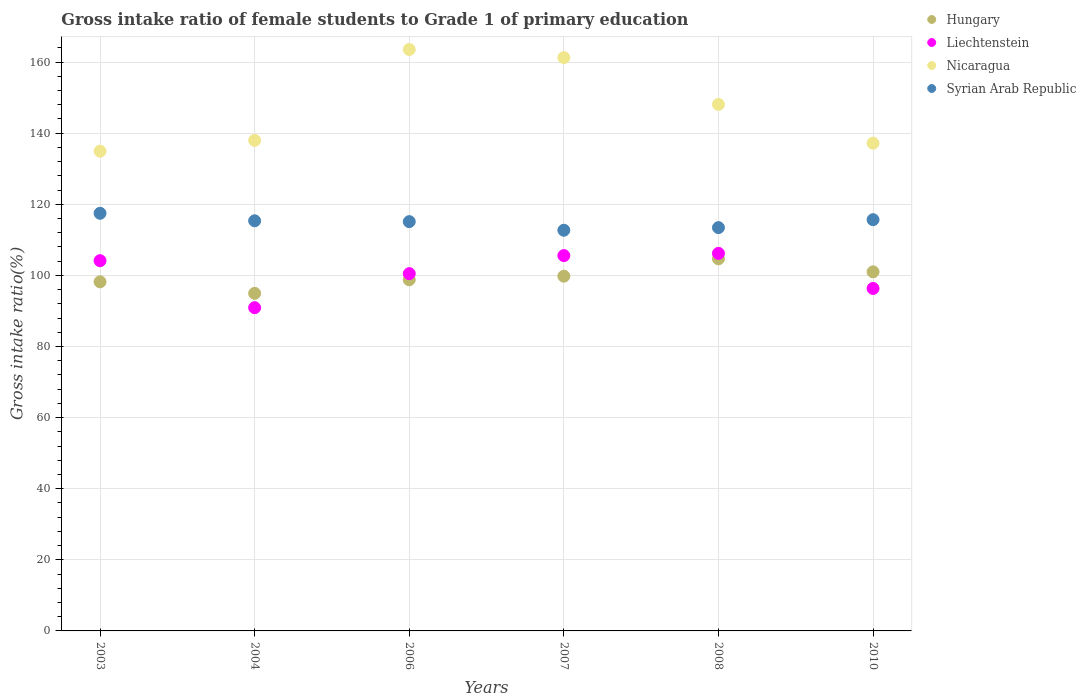How many different coloured dotlines are there?
Offer a very short reply. 4. What is the gross intake ratio in Syrian Arab Republic in 2006?
Ensure brevity in your answer.  115.11. Across all years, what is the maximum gross intake ratio in Liechtenstein?
Keep it short and to the point. 106.19. Across all years, what is the minimum gross intake ratio in Syrian Arab Republic?
Offer a very short reply. 112.68. In which year was the gross intake ratio in Hungary maximum?
Ensure brevity in your answer.  2008. What is the total gross intake ratio in Syrian Arab Republic in the graph?
Offer a very short reply. 689.66. What is the difference between the gross intake ratio in Nicaragua in 2004 and that in 2007?
Your response must be concise. -23.28. What is the difference between the gross intake ratio in Syrian Arab Republic in 2004 and the gross intake ratio in Nicaragua in 2007?
Your answer should be compact. -45.89. What is the average gross intake ratio in Liechtenstein per year?
Keep it short and to the point. 100.6. In the year 2003, what is the difference between the gross intake ratio in Liechtenstein and gross intake ratio in Syrian Arab Republic?
Offer a very short reply. -13.33. What is the ratio of the gross intake ratio in Liechtenstein in 2008 to that in 2010?
Provide a succinct answer. 1.1. Is the difference between the gross intake ratio in Liechtenstein in 2003 and 2004 greater than the difference between the gross intake ratio in Syrian Arab Republic in 2003 and 2004?
Ensure brevity in your answer.  Yes. What is the difference between the highest and the second highest gross intake ratio in Hungary?
Your answer should be very brief. 3.66. What is the difference between the highest and the lowest gross intake ratio in Liechtenstein?
Your answer should be very brief. 15.28. In how many years, is the gross intake ratio in Nicaragua greater than the average gross intake ratio in Nicaragua taken over all years?
Your response must be concise. 3. Is the sum of the gross intake ratio in Nicaragua in 2003 and 2006 greater than the maximum gross intake ratio in Hungary across all years?
Offer a very short reply. Yes. Is it the case that in every year, the sum of the gross intake ratio in Nicaragua and gross intake ratio in Liechtenstein  is greater than the sum of gross intake ratio in Hungary and gross intake ratio in Syrian Arab Republic?
Offer a very short reply. No. Does the gross intake ratio in Hungary monotonically increase over the years?
Provide a short and direct response. No. Is the gross intake ratio in Syrian Arab Republic strictly greater than the gross intake ratio in Hungary over the years?
Your response must be concise. Yes. How many dotlines are there?
Make the answer very short. 4. How many years are there in the graph?
Your response must be concise. 6. Are the values on the major ticks of Y-axis written in scientific E-notation?
Your answer should be compact. No. How many legend labels are there?
Provide a succinct answer. 4. What is the title of the graph?
Provide a short and direct response. Gross intake ratio of female students to Grade 1 of primary education. Does "United States" appear as one of the legend labels in the graph?
Give a very brief answer. No. What is the label or title of the Y-axis?
Your response must be concise. Gross intake ratio(%). What is the Gross intake ratio(%) of Hungary in 2003?
Your response must be concise. 98.18. What is the Gross intake ratio(%) of Liechtenstein in 2003?
Your response must be concise. 104.13. What is the Gross intake ratio(%) in Nicaragua in 2003?
Ensure brevity in your answer.  134.92. What is the Gross intake ratio(%) of Syrian Arab Republic in 2003?
Offer a terse response. 117.46. What is the Gross intake ratio(%) of Hungary in 2004?
Give a very brief answer. 94.94. What is the Gross intake ratio(%) of Liechtenstein in 2004?
Give a very brief answer. 90.91. What is the Gross intake ratio(%) of Nicaragua in 2004?
Your answer should be very brief. 137.96. What is the Gross intake ratio(%) in Syrian Arab Republic in 2004?
Your response must be concise. 115.34. What is the Gross intake ratio(%) in Hungary in 2006?
Make the answer very short. 98.75. What is the Gross intake ratio(%) of Liechtenstein in 2006?
Keep it short and to the point. 100.48. What is the Gross intake ratio(%) of Nicaragua in 2006?
Keep it short and to the point. 163.52. What is the Gross intake ratio(%) of Syrian Arab Republic in 2006?
Give a very brief answer. 115.11. What is the Gross intake ratio(%) of Hungary in 2007?
Make the answer very short. 99.76. What is the Gross intake ratio(%) in Liechtenstein in 2007?
Provide a succinct answer. 105.56. What is the Gross intake ratio(%) in Nicaragua in 2007?
Your response must be concise. 161.24. What is the Gross intake ratio(%) in Syrian Arab Republic in 2007?
Provide a succinct answer. 112.68. What is the Gross intake ratio(%) in Hungary in 2008?
Your response must be concise. 104.65. What is the Gross intake ratio(%) of Liechtenstein in 2008?
Ensure brevity in your answer.  106.19. What is the Gross intake ratio(%) of Nicaragua in 2008?
Your response must be concise. 148.06. What is the Gross intake ratio(%) in Syrian Arab Republic in 2008?
Your response must be concise. 113.42. What is the Gross intake ratio(%) in Hungary in 2010?
Your answer should be compact. 100.99. What is the Gross intake ratio(%) of Liechtenstein in 2010?
Your response must be concise. 96.32. What is the Gross intake ratio(%) of Nicaragua in 2010?
Provide a short and direct response. 137.17. What is the Gross intake ratio(%) of Syrian Arab Republic in 2010?
Offer a very short reply. 115.65. Across all years, what is the maximum Gross intake ratio(%) in Hungary?
Your answer should be very brief. 104.65. Across all years, what is the maximum Gross intake ratio(%) of Liechtenstein?
Make the answer very short. 106.19. Across all years, what is the maximum Gross intake ratio(%) of Nicaragua?
Keep it short and to the point. 163.52. Across all years, what is the maximum Gross intake ratio(%) in Syrian Arab Republic?
Your answer should be compact. 117.46. Across all years, what is the minimum Gross intake ratio(%) in Hungary?
Keep it short and to the point. 94.94. Across all years, what is the minimum Gross intake ratio(%) of Liechtenstein?
Provide a short and direct response. 90.91. Across all years, what is the minimum Gross intake ratio(%) in Nicaragua?
Provide a succinct answer. 134.92. Across all years, what is the minimum Gross intake ratio(%) of Syrian Arab Republic?
Provide a succinct answer. 112.68. What is the total Gross intake ratio(%) in Hungary in the graph?
Make the answer very short. 597.27. What is the total Gross intake ratio(%) in Liechtenstein in the graph?
Keep it short and to the point. 603.58. What is the total Gross intake ratio(%) of Nicaragua in the graph?
Keep it short and to the point. 882.87. What is the total Gross intake ratio(%) of Syrian Arab Republic in the graph?
Offer a terse response. 689.66. What is the difference between the Gross intake ratio(%) in Hungary in 2003 and that in 2004?
Your answer should be compact. 3.24. What is the difference between the Gross intake ratio(%) of Liechtenstein in 2003 and that in 2004?
Offer a terse response. 13.22. What is the difference between the Gross intake ratio(%) in Nicaragua in 2003 and that in 2004?
Your response must be concise. -3.04. What is the difference between the Gross intake ratio(%) in Syrian Arab Republic in 2003 and that in 2004?
Your answer should be compact. 2.11. What is the difference between the Gross intake ratio(%) in Hungary in 2003 and that in 2006?
Ensure brevity in your answer.  -0.57. What is the difference between the Gross intake ratio(%) in Liechtenstein in 2003 and that in 2006?
Give a very brief answer. 3.65. What is the difference between the Gross intake ratio(%) of Nicaragua in 2003 and that in 2006?
Your response must be concise. -28.6. What is the difference between the Gross intake ratio(%) in Syrian Arab Republic in 2003 and that in 2006?
Provide a short and direct response. 2.35. What is the difference between the Gross intake ratio(%) in Hungary in 2003 and that in 2007?
Provide a succinct answer. -1.58. What is the difference between the Gross intake ratio(%) in Liechtenstein in 2003 and that in 2007?
Your answer should be compact. -1.43. What is the difference between the Gross intake ratio(%) in Nicaragua in 2003 and that in 2007?
Your response must be concise. -26.32. What is the difference between the Gross intake ratio(%) of Syrian Arab Republic in 2003 and that in 2007?
Offer a very short reply. 4.77. What is the difference between the Gross intake ratio(%) in Hungary in 2003 and that in 2008?
Provide a succinct answer. -6.47. What is the difference between the Gross intake ratio(%) of Liechtenstein in 2003 and that in 2008?
Your response must be concise. -2.06. What is the difference between the Gross intake ratio(%) in Nicaragua in 2003 and that in 2008?
Ensure brevity in your answer.  -13.15. What is the difference between the Gross intake ratio(%) in Syrian Arab Republic in 2003 and that in 2008?
Offer a terse response. 4.03. What is the difference between the Gross intake ratio(%) in Hungary in 2003 and that in 2010?
Provide a short and direct response. -2.81. What is the difference between the Gross intake ratio(%) in Liechtenstein in 2003 and that in 2010?
Offer a very short reply. 7.81. What is the difference between the Gross intake ratio(%) in Nicaragua in 2003 and that in 2010?
Provide a succinct answer. -2.25. What is the difference between the Gross intake ratio(%) in Syrian Arab Republic in 2003 and that in 2010?
Offer a very short reply. 1.81. What is the difference between the Gross intake ratio(%) of Hungary in 2004 and that in 2006?
Your answer should be compact. -3.82. What is the difference between the Gross intake ratio(%) in Liechtenstein in 2004 and that in 2006?
Provide a short and direct response. -9.57. What is the difference between the Gross intake ratio(%) of Nicaragua in 2004 and that in 2006?
Your answer should be very brief. -25.56. What is the difference between the Gross intake ratio(%) in Syrian Arab Republic in 2004 and that in 2006?
Offer a terse response. 0.23. What is the difference between the Gross intake ratio(%) in Hungary in 2004 and that in 2007?
Offer a very short reply. -4.83. What is the difference between the Gross intake ratio(%) of Liechtenstein in 2004 and that in 2007?
Your response must be concise. -14.65. What is the difference between the Gross intake ratio(%) of Nicaragua in 2004 and that in 2007?
Ensure brevity in your answer.  -23.28. What is the difference between the Gross intake ratio(%) in Syrian Arab Republic in 2004 and that in 2007?
Provide a short and direct response. 2.66. What is the difference between the Gross intake ratio(%) of Hungary in 2004 and that in 2008?
Give a very brief answer. -9.71. What is the difference between the Gross intake ratio(%) of Liechtenstein in 2004 and that in 2008?
Offer a very short reply. -15.28. What is the difference between the Gross intake ratio(%) of Nicaragua in 2004 and that in 2008?
Provide a short and direct response. -10.1. What is the difference between the Gross intake ratio(%) of Syrian Arab Republic in 2004 and that in 2008?
Your answer should be very brief. 1.92. What is the difference between the Gross intake ratio(%) in Hungary in 2004 and that in 2010?
Your response must be concise. -6.05. What is the difference between the Gross intake ratio(%) in Liechtenstein in 2004 and that in 2010?
Offer a terse response. -5.41. What is the difference between the Gross intake ratio(%) in Nicaragua in 2004 and that in 2010?
Give a very brief answer. 0.79. What is the difference between the Gross intake ratio(%) of Syrian Arab Republic in 2004 and that in 2010?
Give a very brief answer. -0.31. What is the difference between the Gross intake ratio(%) of Hungary in 2006 and that in 2007?
Provide a short and direct response. -1.01. What is the difference between the Gross intake ratio(%) in Liechtenstein in 2006 and that in 2007?
Give a very brief answer. -5.07. What is the difference between the Gross intake ratio(%) of Nicaragua in 2006 and that in 2007?
Keep it short and to the point. 2.29. What is the difference between the Gross intake ratio(%) of Syrian Arab Republic in 2006 and that in 2007?
Keep it short and to the point. 2.42. What is the difference between the Gross intake ratio(%) in Hungary in 2006 and that in 2008?
Offer a terse response. -5.9. What is the difference between the Gross intake ratio(%) of Liechtenstein in 2006 and that in 2008?
Provide a succinct answer. -5.7. What is the difference between the Gross intake ratio(%) of Nicaragua in 2006 and that in 2008?
Make the answer very short. 15.46. What is the difference between the Gross intake ratio(%) of Syrian Arab Republic in 2006 and that in 2008?
Give a very brief answer. 1.68. What is the difference between the Gross intake ratio(%) of Hungary in 2006 and that in 2010?
Offer a very short reply. -2.24. What is the difference between the Gross intake ratio(%) in Liechtenstein in 2006 and that in 2010?
Provide a short and direct response. 4.17. What is the difference between the Gross intake ratio(%) in Nicaragua in 2006 and that in 2010?
Make the answer very short. 26.35. What is the difference between the Gross intake ratio(%) of Syrian Arab Republic in 2006 and that in 2010?
Give a very brief answer. -0.54. What is the difference between the Gross intake ratio(%) of Hungary in 2007 and that in 2008?
Provide a short and direct response. -4.89. What is the difference between the Gross intake ratio(%) of Liechtenstein in 2007 and that in 2008?
Your answer should be compact. -0.63. What is the difference between the Gross intake ratio(%) in Nicaragua in 2007 and that in 2008?
Give a very brief answer. 13.17. What is the difference between the Gross intake ratio(%) in Syrian Arab Republic in 2007 and that in 2008?
Offer a very short reply. -0.74. What is the difference between the Gross intake ratio(%) of Hungary in 2007 and that in 2010?
Provide a succinct answer. -1.23. What is the difference between the Gross intake ratio(%) of Liechtenstein in 2007 and that in 2010?
Your answer should be compact. 9.24. What is the difference between the Gross intake ratio(%) of Nicaragua in 2007 and that in 2010?
Provide a succinct answer. 24.07. What is the difference between the Gross intake ratio(%) in Syrian Arab Republic in 2007 and that in 2010?
Make the answer very short. -2.97. What is the difference between the Gross intake ratio(%) of Hungary in 2008 and that in 2010?
Provide a short and direct response. 3.66. What is the difference between the Gross intake ratio(%) in Liechtenstein in 2008 and that in 2010?
Keep it short and to the point. 9.87. What is the difference between the Gross intake ratio(%) of Nicaragua in 2008 and that in 2010?
Provide a succinct answer. 10.9. What is the difference between the Gross intake ratio(%) of Syrian Arab Republic in 2008 and that in 2010?
Your answer should be compact. -2.23. What is the difference between the Gross intake ratio(%) in Hungary in 2003 and the Gross intake ratio(%) in Liechtenstein in 2004?
Keep it short and to the point. 7.27. What is the difference between the Gross intake ratio(%) of Hungary in 2003 and the Gross intake ratio(%) of Nicaragua in 2004?
Offer a terse response. -39.78. What is the difference between the Gross intake ratio(%) in Hungary in 2003 and the Gross intake ratio(%) in Syrian Arab Republic in 2004?
Keep it short and to the point. -17.16. What is the difference between the Gross intake ratio(%) of Liechtenstein in 2003 and the Gross intake ratio(%) of Nicaragua in 2004?
Your response must be concise. -33.83. What is the difference between the Gross intake ratio(%) in Liechtenstein in 2003 and the Gross intake ratio(%) in Syrian Arab Republic in 2004?
Your answer should be very brief. -11.21. What is the difference between the Gross intake ratio(%) of Nicaragua in 2003 and the Gross intake ratio(%) of Syrian Arab Republic in 2004?
Your answer should be compact. 19.58. What is the difference between the Gross intake ratio(%) in Hungary in 2003 and the Gross intake ratio(%) in Liechtenstein in 2006?
Provide a short and direct response. -2.3. What is the difference between the Gross intake ratio(%) of Hungary in 2003 and the Gross intake ratio(%) of Nicaragua in 2006?
Offer a terse response. -65.34. What is the difference between the Gross intake ratio(%) of Hungary in 2003 and the Gross intake ratio(%) of Syrian Arab Republic in 2006?
Your response must be concise. -16.93. What is the difference between the Gross intake ratio(%) of Liechtenstein in 2003 and the Gross intake ratio(%) of Nicaragua in 2006?
Your answer should be compact. -59.39. What is the difference between the Gross intake ratio(%) of Liechtenstein in 2003 and the Gross intake ratio(%) of Syrian Arab Republic in 2006?
Keep it short and to the point. -10.98. What is the difference between the Gross intake ratio(%) of Nicaragua in 2003 and the Gross intake ratio(%) of Syrian Arab Republic in 2006?
Keep it short and to the point. 19.81. What is the difference between the Gross intake ratio(%) of Hungary in 2003 and the Gross intake ratio(%) of Liechtenstein in 2007?
Give a very brief answer. -7.38. What is the difference between the Gross intake ratio(%) of Hungary in 2003 and the Gross intake ratio(%) of Nicaragua in 2007?
Make the answer very short. -63.06. What is the difference between the Gross intake ratio(%) in Hungary in 2003 and the Gross intake ratio(%) in Syrian Arab Republic in 2007?
Offer a terse response. -14.5. What is the difference between the Gross intake ratio(%) in Liechtenstein in 2003 and the Gross intake ratio(%) in Nicaragua in 2007?
Your response must be concise. -57.11. What is the difference between the Gross intake ratio(%) of Liechtenstein in 2003 and the Gross intake ratio(%) of Syrian Arab Republic in 2007?
Ensure brevity in your answer.  -8.56. What is the difference between the Gross intake ratio(%) of Nicaragua in 2003 and the Gross intake ratio(%) of Syrian Arab Republic in 2007?
Provide a short and direct response. 22.23. What is the difference between the Gross intake ratio(%) in Hungary in 2003 and the Gross intake ratio(%) in Liechtenstein in 2008?
Offer a terse response. -8.01. What is the difference between the Gross intake ratio(%) of Hungary in 2003 and the Gross intake ratio(%) of Nicaragua in 2008?
Keep it short and to the point. -49.88. What is the difference between the Gross intake ratio(%) of Hungary in 2003 and the Gross intake ratio(%) of Syrian Arab Republic in 2008?
Provide a short and direct response. -15.24. What is the difference between the Gross intake ratio(%) of Liechtenstein in 2003 and the Gross intake ratio(%) of Nicaragua in 2008?
Provide a short and direct response. -43.94. What is the difference between the Gross intake ratio(%) of Liechtenstein in 2003 and the Gross intake ratio(%) of Syrian Arab Republic in 2008?
Your answer should be compact. -9.29. What is the difference between the Gross intake ratio(%) of Nicaragua in 2003 and the Gross intake ratio(%) of Syrian Arab Republic in 2008?
Give a very brief answer. 21.5. What is the difference between the Gross intake ratio(%) in Hungary in 2003 and the Gross intake ratio(%) in Liechtenstein in 2010?
Your answer should be compact. 1.86. What is the difference between the Gross intake ratio(%) of Hungary in 2003 and the Gross intake ratio(%) of Nicaragua in 2010?
Give a very brief answer. -38.99. What is the difference between the Gross intake ratio(%) in Hungary in 2003 and the Gross intake ratio(%) in Syrian Arab Republic in 2010?
Ensure brevity in your answer.  -17.47. What is the difference between the Gross intake ratio(%) of Liechtenstein in 2003 and the Gross intake ratio(%) of Nicaragua in 2010?
Ensure brevity in your answer.  -33.04. What is the difference between the Gross intake ratio(%) in Liechtenstein in 2003 and the Gross intake ratio(%) in Syrian Arab Republic in 2010?
Keep it short and to the point. -11.52. What is the difference between the Gross intake ratio(%) of Nicaragua in 2003 and the Gross intake ratio(%) of Syrian Arab Republic in 2010?
Offer a terse response. 19.27. What is the difference between the Gross intake ratio(%) of Hungary in 2004 and the Gross intake ratio(%) of Liechtenstein in 2006?
Ensure brevity in your answer.  -5.55. What is the difference between the Gross intake ratio(%) in Hungary in 2004 and the Gross intake ratio(%) in Nicaragua in 2006?
Your answer should be very brief. -68.59. What is the difference between the Gross intake ratio(%) in Hungary in 2004 and the Gross intake ratio(%) in Syrian Arab Republic in 2006?
Provide a short and direct response. -20.17. What is the difference between the Gross intake ratio(%) of Liechtenstein in 2004 and the Gross intake ratio(%) of Nicaragua in 2006?
Provide a succinct answer. -72.61. What is the difference between the Gross intake ratio(%) of Liechtenstein in 2004 and the Gross intake ratio(%) of Syrian Arab Republic in 2006?
Make the answer very short. -24.2. What is the difference between the Gross intake ratio(%) of Nicaragua in 2004 and the Gross intake ratio(%) of Syrian Arab Republic in 2006?
Provide a succinct answer. 22.85. What is the difference between the Gross intake ratio(%) in Hungary in 2004 and the Gross intake ratio(%) in Liechtenstein in 2007?
Make the answer very short. -10.62. What is the difference between the Gross intake ratio(%) in Hungary in 2004 and the Gross intake ratio(%) in Nicaragua in 2007?
Make the answer very short. -66.3. What is the difference between the Gross intake ratio(%) of Hungary in 2004 and the Gross intake ratio(%) of Syrian Arab Republic in 2007?
Offer a terse response. -17.75. What is the difference between the Gross intake ratio(%) in Liechtenstein in 2004 and the Gross intake ratio(%) in Nicaragua in 2007?
Ensure brevity in your answer.  -70.33. What is the difference between the Gross intake ratio(%) of Liechtenstein in 2004 and the Gross intake ratio(%) of Syrian Arab Republic in 2007?
Provide a short and direct response. -21.77. What is the difference between the Gross intake ratio(%) in Nicaragua in 2004 and the Gross intake ratio(%) in Syrian Arab Republic in 2007?
Ensure brevity in your answer.  25.28. What is the difference between the Gross intake ratio(%) in Hungary in 2004 and the Gross intake ratio(%) in Liechtenstein in 2008?
Give a very brief answer. -11.25. What is the difference between the Gross intake ratio(%) of Hungary in 2004 and the Gross intake ratio(%) of Nicaragua in 2008?
Provide a succinct answer. -53.13. What is the difference between the Gross intake ratio(%) of Hungary in 2004 and the Gross intake ratio(%) of Syrian Arab Republic in 2008?
Provide a succinct answer. -18.49. What is the difference between the Gross intake ratio(%) in Liechtenstein in 2004 and the Gross intake ratio(%) in Nicaragua in 2008?
Keep it short and to the point. -57.15. What is the difference between the Gross intake ratio(%) in Liechtenstein in 2004 and the Gross intake ratio(%) in Syrian Arab Republic in 2008?
Your answer should be compact. -22.51. What is the difference between the Gross intake ratio(%) in Nicaragua in 2004 and the Gross intake ratio(%) in Syrian Arab Republic in 2008?
Your response must be concise. 24.54. What is the difference between the Gross intake ratio(%) of Hungary in 2004 and the Gross intake ratio(%) of Liechtenstein in 2010?
Provide a succinct answer. -1.38. What is the difference between the Gross intake ratio(%) of Hungary in 2004 and the Gross intake ratio(%) of Nicaragua in 2010?
Provide a succinct answer. -42.23. What is the difference between the Gross intake ratio(%) in Hungary in 2004 and the Gross intake ratio(%) in Syrian Arab Republic in 2010?
Provide a short and direct response. -20.71. What is the difference between the Gross intake ratio(%) of Liechtenstein in 2004 and the Gross intake ratio(%) of Nicaragua in 2010?
Give a very brief answer. -46.26. What is the difference between the Gross intake ratio(%) in Liechtenstein in 2004 and the Gross intake ratio(%) in Syrian Arab Republic in 2010?
Your answer should be very brief. -24.74. What is the difference between the Gross intake ratio(%) in Nicaragua in 2004 and the Gross intake ratio(%) in Syrian Arab Republic in 2010?
Ensure brevity in your answer.  22.31. What is the difference between the Gross intake ratio(%) of Hungary in 2006 and the Gross intake ratio(%) of Liechtenstein in 2007?
Make the answer very short. -6.8. What is the difference between the Gross intake ratio(%) of Hungary in 2006 and the Gross intake ratio(%) of Nicaragua in 2007?
Make the answer very short. -62.48. What is the difference between the Gross intake ratio(%) in Hungary in 2006 and the Gross intake ratio(%) in Syrian Arab Republic in 2007?
Provide a succinct answer. -13.93. What is the difference between the Gross intake ratio(%) in Liechtenstein in 2006 and the Gross intake ratio(%) in Nicaragua in 2007?
Provide a succinct answer. -60.75. What is the difference between the Gross intake ratio(%) in Liechtenstein in 2006 and the Gross intake ratio(%) in Syrian Arab Republic in 2007?
Your response must be concise. -12.2. What is the difference between the Gross intake ratio(%) in Nicaragua in 2006 and the Gross intake ratio(%) in Syrian Arab Republic in 2007?
Offer a very short reply. 50.84. What is the difference between the Gross intake ratio(%) of Hungary in 2006 and the Gross intake ratio(%) of Liechtenstein in 2008?
Make the answer very short. -7.43. What is the difference between the Gross intake ratio(%) of Hungary in 2006 and the Gross intake ratio(%) of Nicaragua in 2008?
Provide a succinct answer. -49.31. What is the difference between the Gross intake ratio(%) of Hungary in 2006 and the Gross intake ratio(%) of Syrian Arab Republic in 2008?
Offer a terse response. -14.67. What is the difference between the Gross intake ratio(%) of Liechtenstein in 2006 and the Gross intake ratio(%) of Nicaragua in 2008?
Give a very brief answer. -47.58. What is the difference between the Gross intake ratio(%) of Liechtenstein in 2006 and the Gross intake ratio(%) of Syrian Arab Republic in 2008?
Offer a terse response. -12.94. What is the difference between the Gross intake ratio(%) in Nicaragua in 2006 and the Gross intake ratio(%) in Syrian Arab Republic in 2008?
Provide a short and direct response. 50.1. What is the difference between the Gross intake ratio(%) in Hungary in 2006 and the Gross intake ratio(%) in Liechtenstein in 2010?
Keep it short and to the point. 2.44. What is the difference between the Gross intake ratio(%) in Hungary in 2006 and the Gross intake ratio(%) in Nicaragua in 2010?
Provide a succinct answer. -38.41. What is the difference between the Gross intake ratio(%) in Hungary in 2006 and the Gross intake ratio(%) in Syrian Arab Republic in 2010?
Your answer should be very brief. -16.9. What is the difference between the Gross intake ratio(%) in Liechtenstein in 2006 and the Gross intake ratio(%) in Nicaragua in 2010?
Your answer should be compact. -36.68. What is the difference between the Gross intake ratio(%) in Liechtenstein in 2006 and the Gross intake ratio(%) in Syrian Arab Republic in 2010?
Provide a short and direct response. -15.17. What is the difference between the Gross intake ratio(%) of Nicaragua in 2006 and the Gross intake ratio(%) of Syrian Arab Republic in 2010?
Give a very brief answer. 47.87. What is the difference between the Gross intake ratio(%) of Hungary in 2007 and the Gross intake ratio(%) of Liechtenstein in 2008?
Provide a short and direct response. -6.42. What is the difference between the Gross intake ratio(%) in Hungary in 2007 and the Gross intake ratio(%) in Nicaragua in 2008?
Provide a succinct answer. -48.3. What is the difference between the Gross intake ratio(%) in Hungary in 2007 and the Gross intake ratio(%) in Syrian Arab Republic in 2008?
Your answer should be compact. -13.66. What is the difference between the Gross intake ratio(%) of Liechtenstein in 2007 and the Gross intake ratio(%) of Nicaragua in 2008?
Offer a very short reply. -42.51. What is the difference between the Gross intake ratio(%) in Liechtenstein in 2007 and the Gross intake ratio(%) in Syrian Arab Republic in 2008?
Your answer should be very brief. -7.87. What is the difference between the Gross intake ratio(%) of Nicaragua in 2007 and the Gross intake ratio(%) of Syrian Arab Republic in 2008?
Provide a short and direct response. 47.81. What is the difference between the Gross intake ratio(%) in Hungary in 2007 and the Gross intake ratio(%) in Liechtenstein in 2010?
Offer a very short reply. 3.45. What is the difference between the Gross intake ratio(%) of Hungary in 2007 and the Gross intake ratio(%) of Nicaragua in 2010?
Give a very brief answer. -37.41. What is the difference between the Gross intake ratio(%) in Hungary in 2007 and the Gross intake ratio(%) in Syrian Arab Republic in 2010?
Make the answer very short. -15.89. What is the difference between the Gross intake ratio(%) in Liechtenstein in 2007 and the Gross intake ratio(%) in Nicaragua in 2010?
Your response must be concise. -31.61. What is the difference between the Gross intake ratio(%) in Liechtenstein in 2007 and the Gross intake ratio(%) in Syrian Arab Republic in 2010?
Keep it short and to the point. -10.09. What is the difference between the Gross intake ratio(%) in Nicaragua in 2007 and the Gross intake ratio(%) in Syrian Arab Republic in 2010?
Your answer should be very brief. 45.59. What is the difference between the Gross intake ratio(%) in Hungary in 2008 and the Gross intake ratio(%) in Liechtenstein in 2010?
Your answer should be very brief. 8.33. What is the difference between the Gross intake ratio(%) of Hungary in 2008 and the Gross intake ratio(%) of Nicaragua in 2010?
Offer a terse response. -32.52. What is the difference between the Gross intake ratio(%) in Hungary in 2008 and the Gross intake ratio(%) in Syrian Arab Republic in 2010?
Give a very brief answer. -11. What is the difference between the Gross intake ratio(%) of Liechtenstein in 2008 and the Gross intake ratio(%) of Nicaragua in 2010?
Provide a succinct answer. -30.98. What is the difference between the Gross intake ratio(%) of Liechtenstein in 2008 and the Gross intake ratio(%) of Syrian Arab Republic in 2010?
Offer a very short reply. -9.46. What is the difference between the Gross intake ratio(%) in Nicaragua in 2008 and the Gross intake ratio(%) in Syrian Arab Republic in 2010?
Provide a short and direct response. 32.41. What is the average Gross intake ratio(%) in Hungary per year?
Your response must be concise. 99.54. What is the average Gross intake ratio(%) of Liechtenstein per year?
Give a very brief answer. 100.6. What is the average Gross intake ratio(%) of Nicaragua per year?
Keep it short and to the point. 147.14. What is the average Gross intake ratio(%) in Syrian Arab Republic per year?
Give a very brief answer. 114.94. In the year 2003, what is the difference between the Gross intake ratio(%) in Hungary and Gross intake ratio(%) in Liechtenstein?
Offer a very short reply. -5.95. In the year 2003, what is the difference between the Gross intake ratio(%) in Hungary and Gross intake ratio(%) in Nicaragua?
Keep it short and to the point. -36.74. In the year 2003, what is the difference between the Gross intake ratio(%) of Hungary and Gross intake ratio(%) of Syrian Arab Republic?
Keep it short and to the point. -19.28. In the year 2003, what is the difference between the Gross intake ratio(%) of Liechtenstein and Gross intake ratio(%) of Nicaragua?
Offer a terse response. -30.79. In the year 2003, what is the difference between the Gross intake ratio(%) in Liechtenstein and Gross intake ratio(%) in Syrian Arab Republic?
Provide a short and direct response. -13.33. In the year 2003, what is the difference between the Gross intake ratio(%) of Nicaragua and Gross intake ratio(%) of Syrian Arab Republic?
Offer a terse response. 17.46. In the year 2004, what is the difference between the Gross intake ratio(%) of Hungary and Gross intake ratio(%) of Liechtenstein?
Your answer should be compact. 4.03. In the year 2004, what is the difference between the Gross intake ratio(%) in Hungary and Gross intake ratio(%) in Nicaragua?
Offer a terse response. -43.02. In the year 2004, what is the difference between the Gross intake ratio(%) of Hungary and Gross intake ratio(%) of Syrian Arab Republic?
Keep it short and to the point. -20.41. In the year 2004, what is the difference between the Gross intake ratio(%) of Liechtenstein and Gross intake ratio(%) of Nicaragua?
Your response must be concise. -47.05. In the year 2004, what is the difference between the Gross intake ratio(%) of Liechtenstein and Gross intake ratio(%) of Syrian Arab Republic?
Offer a terse response. -24.43. In the year 2004, what is the difference between the Gross intake ratio(%) in Nicaragua and Gross intake ratio(%) in Syrian Arab Republic?
Make the answer very short. 22.62. In the year 2006, what is the difference between the Gross intake ratio(%) of Hungary and Gross intake ratio(%) of Liechtenstein?
Provide a succinct answer. -1.73. In the year 2006, what is the difference between the Gross intake ratio(%) of Hungary and Gross intake ratio(%) of Nicaragua?
Your answer should be very brief. -64.77. In the year 2006, what is the difference between the Gross intake ratio(%) in Hungary and Gross intake ratio(%) in Syrian Arab Republic?
Your answer should be very brief. -16.35. In the year 2006, what is the difference between the Gross intake ratio(%) of Liechtenstein and Gross intake ratio(%) of Nicaragua?
Offer a terse response. -63.04. In the year 2006, what is the difference between the Gross intake ratio(%) of Liechtenstein and Gross intake ratio(%) of Syrian Arab Republic?
Your answer should be very brief. -14.62. In the year 2006, what is the difference between the Gross intake ratio(%) in Nicaragua and Gross intake ratio(%) in Syrian Arab Republic?
Provide a short and direct response. 48.41. In the year 2007, what is the difference between the Gross intake ratio(%) of Hungary and Gross intake ratio(%) of Liechtenstein?
Provide a short and direct response. -5.79. In the year 2007, what is the difference between the Gross intake ratio(%) in Hungary and Gross intake ratio(%) in Nicaragua?
Provide a succinct answer. -61.47. In the year 2007, what is the difference between the Gross intake ratio(%) in Hungary and Gross intake ratio(%) in Syrian Arab Republic?
Ensure brevity in your answer.  -12.92. In the year 2007, what is the difference between the Gross intake ratio(%) of Liechtenstein and Gross intake ratio(%) of Nicaragua?
Your answer should be compact. -55.68. In the year 2007, what is the difference between the Gross intake ratio(%) of Liechtenstein and Gross intake ratio(%) of Syrian Arab Republic?
Ensure brevity in your answer.  -7.13. In the year 2007, what is the difference between the Gross intake ratio(%) of Nicaragua and Gross intake ratio(%) of Syrian Arab Republic?
Make the answer very short. 48.55. In the year 2008, what is the difference between the Gross intake ratio(%) in Hungary and Gross intake ratio(%) in Liechtenstein?
Your answer should be compact. -1.54. In the year 2008, what is the difference between the Gross intake ratio(%) of Hungary and Gross intake ratio(%) of Nicaragua?
Make the answer very short. -43.41. In the year 2008, what is the difference between the Gross intake ratio(%) in Hungary and Gross intake ratio(%) in Syrian Arab Republic?
Your response must be concise. -8.77. In the year 2008, what is the difference between the Gross intake ratio(%) in Liechtenstein and Gross intake ratio(%) in Nicaragua?
Your response must be concise. -41.88. In the year 2008, what is the difference between the Gross intake ratio(%) of Liechtenstein and Gross intake ratio(%) of Syrian Arab Republic?
Your answer should be very brief. -7.24. In the year 2008, what is the difference between the Gross intake ratio(%) in Nicaragua and Gross intake ratio(%) in Syrian Arab Republic?
Your response must be concise. 34.64. In the year 2010, what is the difference between the Gross intake ratio(%) in Hungary and Gross intake ratio(%) in Liechtenstein?
Give a very brief answer. 4.67. In the year 2010, what is the difference between the Gross intake ratio(%) of Hungary and Gross intake ratio(%) of Nicaragua?
Your answer should be compact. -36.18. In the year 2010, what is the difference between the Gross intake ratio(%) of Hungary and Gross intake ratio(%) of Syrian Arab Republic?
Provide a short and direct response. -14.66. In the year 2010, what is the difference between the Gross intake ratio(%) in Liechtenstein and Gross intake ratio(%) in Nicaragua?
Keep it short and to the point. -40.85. In the year 2010, what is the difference between the Gross intake ratio(%) in Liechtenstein and Gross intake ratio(%) in Syrian Arab Republic?
Offer a very short reply. -19.33. In the year 2010, what is the difference between the Gross intake ratio(%) in Nicaragua and Gross intake ratio(%) in Syrian Arab Republic?
Your answer should be compact. 21.52. What is the ratio of the Gross intake ratio(%) of Hungary in 2003 to that in 2004?
Keep it short and to the point. 1.03. What is the ratio of the Gross intake ratio(%) of Liechtenstein in 2003 to that in 2004?
Make the answer very short. 1.15. What is the ratio of the Gross intake ratio(%) of Syrian Arab Republic in 2003 to that in 2004?
Ensure brevity in your answer.  1.02. What is the ratio of the Gross intake ratio(%) of Liechtenstein in 2003 to that in 2006?
Ensure brevity in your answer.  1.04. What is the ratio of the Gross intake ratio(%) of Nicaragua in 2003 to that in 2006?
Your answer should be compact. 0.83. What is the ratio of the Gross intake ratio(%) of Syrian Arab Republic in 2003 to that in 2006?
Offer a terse response. 1.02. What is the ratio of the Gross intake ratio(%) of Hungary in 2003 to that in 2007?
Your answer should be compact. 0.98. What is the ratio of the Gross intake ratio(%) in Liechtenstein in 2003 to that in 2007?
Your answer should be compact. 0.99. What is the ratio of the Gross intake ratio(%) of Nicaragua in 2003 to that in 2007?
Offer a very short reply. 0.84. What is the ratio of the Gross intake ratio(%) of Syrian Arab Republic in 2003 to that in 2007?
Your response must be concise. 1.04. What is the ratio of the Gross intake ratio(%) of Hungary in 2003 to that in 2008?
Provide a short and direct response. 0.94. What is the ratio of the Gross intake ratio(%) in Liechtenstein in 2003 to that in 2008?
Provide a short and direct response. 0.98. What is the ratio of the Gross intake ratio(%) of Nicaragua in 2003 to that in 2008?
Offer a terse response. 0.91. What is the ratio of the Gross intake ratio(%) of Syrian Arab Republic in 2003 to that in 2008?
Offer a terse response. 1.04. What is the ratio of the Gross intake ratio(%) of Hungary in 2003 to that in 2010?
Ensure brevity in your answer.  0.97. What is the ratio of the Gross intake ratio(%) in Liechtenstein in 2003 to that in 2010?
Make the answer very short. 1.08. What is the ratio of the Gross intake ratio(%) in Nicaragua in 2003 to that in 2010?
Ensure brevity in your answer.  0.98. What is the ratio of the Gross intake ratio(%) in Syrian Arab Republic in 2003 to that in 2010?
Your answer should be very brief. 1.02. What is the ratio of the Gross intake ratio(%) of Hungary in 2004 to that in 2006?
Your response must be concise. 0.96. What is the ratio of the Gross intake ratio(%) in Liechtenstein in 2004 to that in 2006?
Provide a succinct answer. 0.9. What is the ratio of the Gross intake ratio(%) in Nicaragua in 2004 to that in 2006?
Provide a succinct answer. 0.84. What is the ratio of the Gross intake ratio(%) of Syrian Arab Republic in 2004 to that in 2006?
Ensure brevity in your answer.  1. What is the ratio of the Gross intake ratio(%) in Hungary in 2004 to that in 2007?
Offer a very short reply. 0.95. What is the ratio of the Gross intake ratio(%) of Liechtenstein in 2004 to that in 2007?
Give a very brief answer. 0.86. What is the ratio of the Gross intake ratio(%) of Nicaragua in 2004 to that in 2007?
Your answer should be very brief. 0.86. What is the ratio of the Gross intake ratio(%) of Syrian Arab Republic in 2004 to that in 2007?
Your answer should be compact. 1.02. What is the ratio of the Gross intake ratio(%) of Hungary in 2004 to that in 2008?
Your response must be concise. 0.91. What is the ratio of the Gross intake ratio(%) in Liechtenstein in 2004 to that in 2008?
Offer a very short reply. 0.86. What is the ratio of the Gross intake ratio(%) of Nicaragua in 2004 to that in 2008?
Your answer should be compact. 0.93. What is the ratio of the Gross intake ratio(%) of Syrian Arab Republic in 2004 to that in 2008?
Offer a very short reply. 1.02. What is the ratio of the Gross intake ratio(%) of Hungary in 2004 to that in 2010?
Give a very brief answer. 0.94. What is the ratio of the Gross intake ratio(%) in Liechtenstein in 2004 to that in 2010?
Offer a terse response. 0.94. What is the ratio of the Gross intake ratio(%) in Liechtenstein in 2006 to that in 2007?
Your answer should be very brief. 0.95. What is the ratio of the Gross intake ratio(%) in Nicaragua in 2006 to that in 2007?
Offer a very short reply. 1.01. What is the ratio of the Gross intake ratio(%) in Syrian Arab Republic in 2006 to that in 2007?
Your answer should be compact. 1.02. What is the ratio of the Gross intake ratio(%) in Hungary in 2006 to that in 2008?
Make the answer very short. 0.94. What is the ratio of the Gross intake ratio(%) of Liechtenstein in 2006 to that in 2008?
Your answer should be compact. 0.95. What is the ratio of the Gross intake ratio(%) in Nicaragua in 2006 to that in 2008?
Make the answer very short. 1.1. What is the ratio of the Gross intake ratio(%) of Syrian Arab Republic in 2006 to that in 2008?
Your response must be concise. 1.01. What is the ratio of the Gross intake ratio(%) of Hungary in 2006 to that in 2010?
Ensure brevity in your answer.  0.98. What is the ratio of the Gross intake ratio(%) in Liechtenstein in 2006 to that in 2010?
Provide a succinct answer. 1.04. What is the ratio of the Gross intake ratio(%) in Nicaragua in 2006 to that in 2010?
Offer a very short reply. 1.19. What is the ratio of the Gross intake ratio(%) of Syrian Arab Republic in 2006 to that in 2010?
Offer a terse response. 1. What is the ratio of the Gross intake ratio(%) of Hungary in 2007 to that in 2008?
Provide a succinct answer. 0.95. What is the ratio of the Gross intake ratio(%) in Nicaragua in 2007 to that in 2008?
Offer a very short reply. 1.09. What is the ratio of the Gross intake ratio(%) of Syrian Arab Republic in 2007 to that in 2008?
Ensure brevity in your answer.  0.99. What is the ratio of the Gross intake ratio(%) in Hungary in 2007 to that in 2010?
Your answer should be very brief. 0.99. What is the ratio of the Gross intake ratio(%) in Liechtenstein in 2007 to that in 2010?
Provide a succinct answer. 1.1. What is the ratio of the Gross intake ratio(%) of Nicaragua in 2007 to that in 2010?
Your response must be concise. 1.18. What is the ratio of the Gross intake ratio(%) in Syrian Arab Republic in 2007 to that in 2010?
Your response must be concise. 0.97. What is the ratio of the Gross intake ratio(%) in Hungary in 2008 to that in 2010?
Provide a short and direct response. 1.04. What is the ratio of the Gross intake ratio(%) of Liechtenstein in 2008 to that in 2010?
Provide a short and direct response. 1.1. What is the ratio of the Gross intake ratio(%) of Nicaragua in 2008 to that in 2010?
Keep it short and to the point. 1.08. What is the ratio of the Gross intake ratio(%) in Syrian Arab Republic in 2008 to that in 2010?
Make the answer very short. 0.98. What is the difference between the highest and the second highest Gross intake ratio(%) of Hungary?
Keep it short and to the point. 3.66. What is the difference between the highest and the second highest Gross intake ratio(%) in Liechtenstein?
Offer a terse response. 0.63. What is the difference between the highest and the second highest Gross intake ratio(%) of Nicaragua?
Give a very brief answer. 2.29. What is the difference between the highest and the second highest Gross intake ratio(%) of Syrian Arab Republic?
Your answer should be compact. 1.81. What is the difference between the highest and the lowest Gross intake ratio(%) in Hungary?
Provide a succinct answer. 9.71. What is the difference between the highest and the lowest Gross intake ratio(%) in Liechtenstein?
Offer a very short reply. 15.28. What is the difference between the highest and the lowest Gross intake ratio(%) in Nicaragua?
Ensure brevity in your answer.  28.6. What is the difference between the highest and the lowest Gross intake ratio(%) of Syrian Arab Republic?
Ensure brevity in your answer.  4.77. 